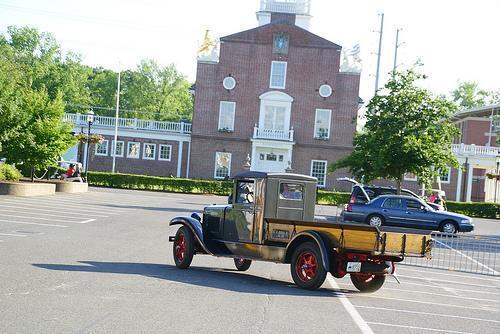How many cars are antique style?
Give a very brief answer. 1. 